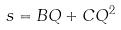<formula> <loc_0><loc_0><loc_500><loc_500>s = B Q + C Q ^ { 2 }</formula> 